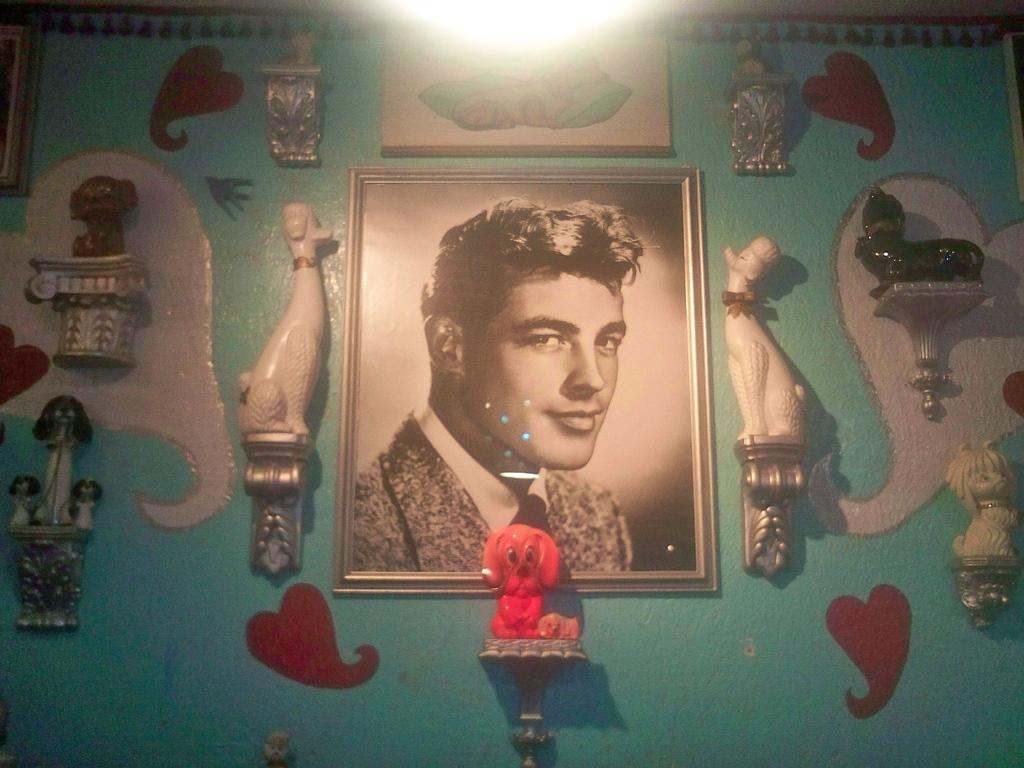What is the main feature in the center of the image? There is a wall in the center of the image. What is placed on the wall? There is a photo frame and toys on the wall. What type of decoration is present on the wall? There is artwork on the wall. What type of sheet is covering the toys on the wall? There is no sheet covering the toys on the wall in the image. What emotion is expressed by the artwork on the wall? The emotion expressed by the artwork cannot be determined from the image alone. 